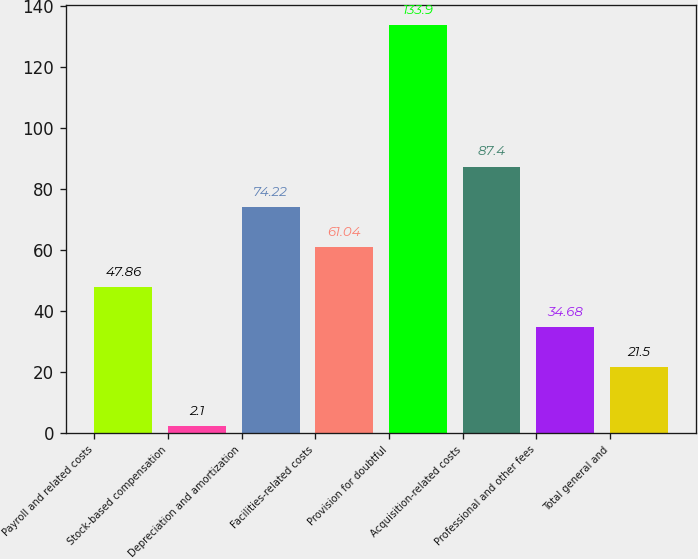Convert chart. <chart><loc_0><loc_0><loc_500><loc_500><bar_chart><fcel>Payroll and related costs<fcel>Stock-based compensation<fcel>Depreciation and amortization<fcel>Facilities-related costs<fcel>Provision for doubtful<fcel>Acquisition-related costs<fcel>Professional and other fees<fcel>Total general and<nl><fcel>47.86<fcel>2.1<fcel>74.22<fcel>61.04<fcel>133.9<fcel>87.4<fcel>34.68<fcel>21.5<nl></chart> 